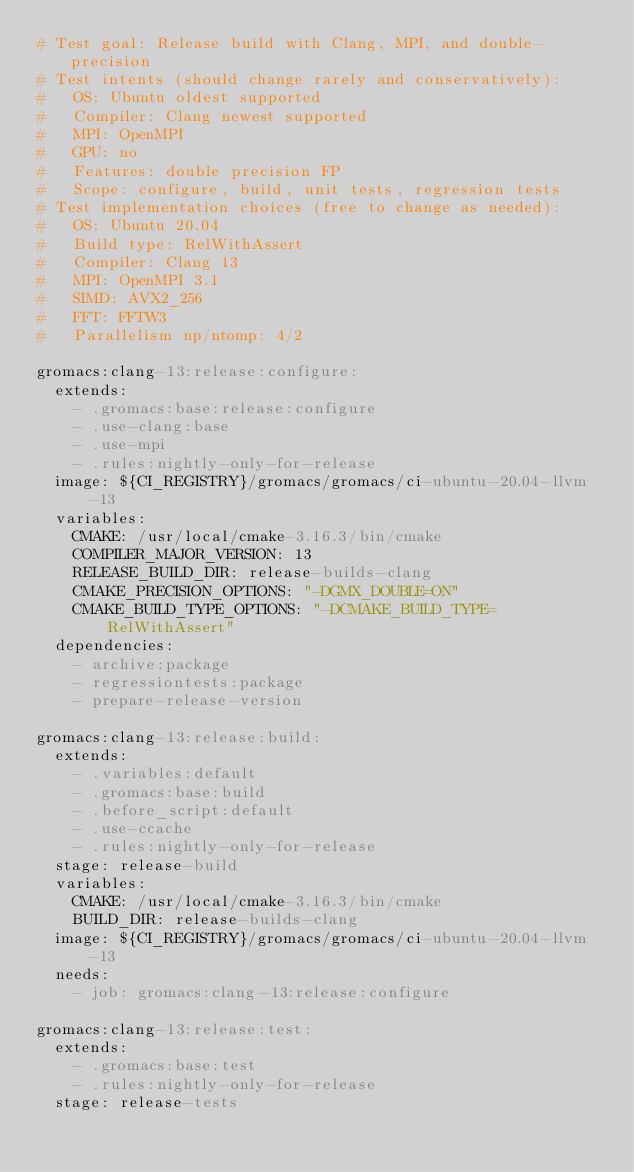<code> <loc_0><loc_0><loc_500><loc_500><_YAML_># Test goal: Release build with Clang, MPI, and double-precision
# Test intents (should change rarely and conservatively):
#   OS: Ubuntu oldest supported
#   Compiler: Clang newest supported
#   MPI: OpenMPI
#   GPU: no
#   Features: double precision FP
#   Scope: configure, build, unit tests, regression tests
# Test implementation choices (free to change as needed):
#   OS: Ubuntu 20.04
#   Build type: RelWithAssert
#   Compiler: Clang 13
#   MPI: OpenMPI 3.1
#   SIMD: AVX2_256
#   FFT: FFTW3
#   Parallelism np/ntomp: 4/2

gromacs:clang-13:release:configure:
  extends:
    - .gromacs:base:release:configure
    - .use-clang:base
    - .use-mpi
    - .rules:nightly-only-for-release
  image: ${CI_REGISTRY}/gromacs/gromacs/ci-ubuntu-20.04-llvm-13
  variables:
    CMAKE: /usr/local/cmake-3.16.3/bin/cmake
    COMPILER_MAJOR_VERSION: 13
    RELEASE_BUILD_DIR: release-builds-clang
    CMAKE_PRECISION_OPTIONS: "-DGMX_DOUBLE=ON"
    CMAKE_BUILD_TYPE_OPTIONS: "-DCMAKE_BUILD_TYPE=RelWithAssert"
  dependencies:
    - archive:package
    - regressiontests:package
    - prepare-release-version

gromacs:clang-13:release:build:
  extends:
    - .variables:default
    - .gromacs:base:build
    - .before_script:default
    - .use-ccache
    - .rules:nightly-only-for-release
  stage: release-build
  variables:
    CMAKE: /usr/local/cmake-3.16.3/bin/cmake
    BUILD_DIR: release-builds-clang
  image: ${CI_REGISTRY}/gromacs/gromacs/ci-ubuntu-20.04-llvm-13
  needs:
    - job: gromacs:clang-13:release:configure

gromacs:clang-13:release:test:
  extends:
    - .gromacs:base:test
    - .rules:nightly-only-for-release
  stage: release-tests</code> 